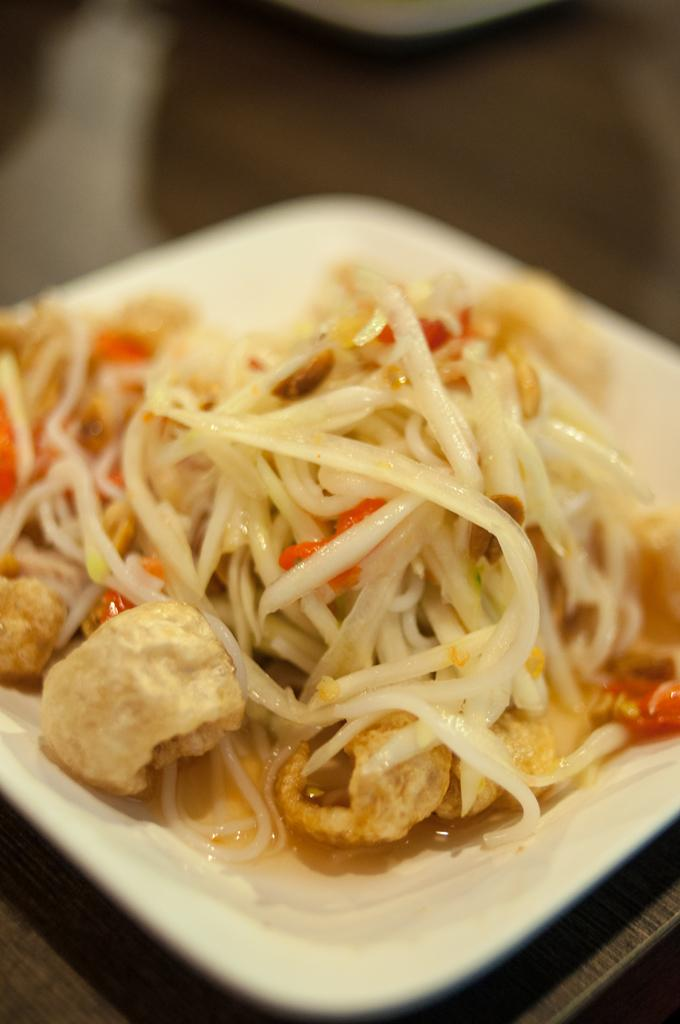What is the main subject of the image? The main subject of the image is a zoomed-in picture of food. How is the food arranged in the image? The food is present on a plate. What type of surface is the plate resting on? The plate is on a wooden surface. What color is the copper milk jug on the wooden surface in the image? There is no copper milk jug present in the image; it only features a plate of food. 